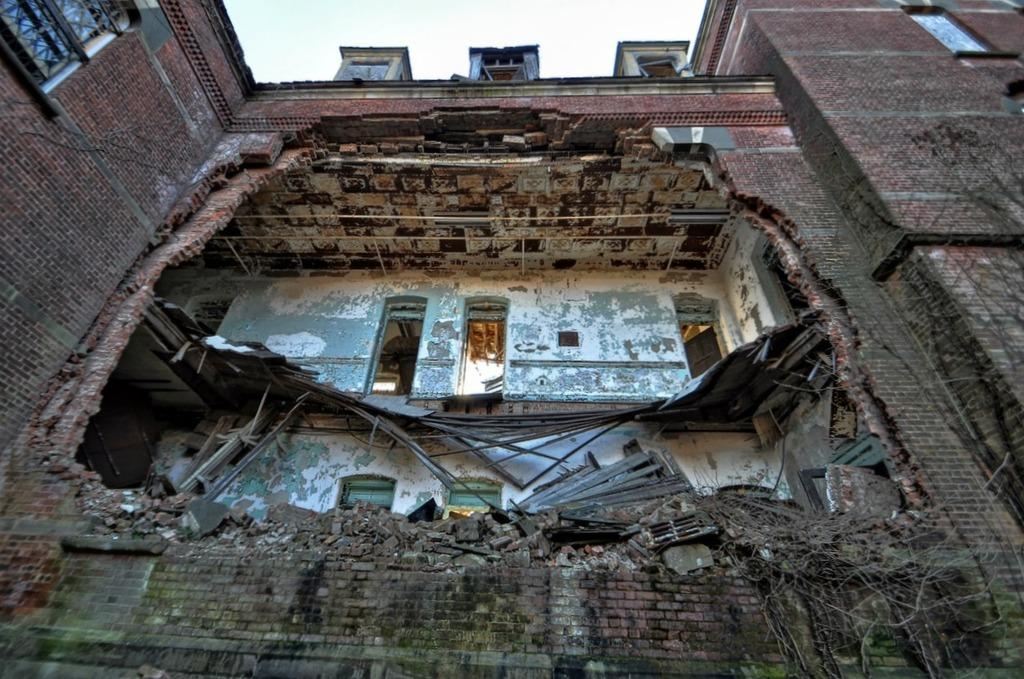What is the main subject of the image? The main subject of the image is a building. What is the condition of the building in the image? The building has collapsed in the image. What type of cheese can be seen on the woman's bag in the image? There is no woman or bag present in the image, and therefore no cheese can be seen. 